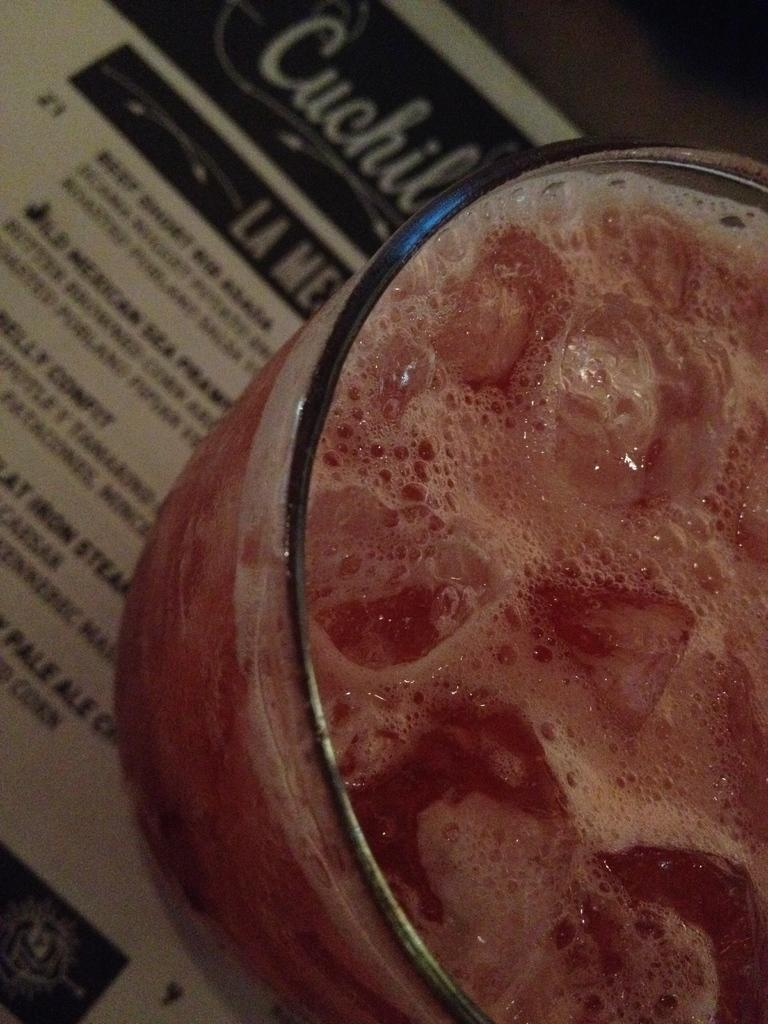What is in the glass that is visible in the image? There is a drink in the glass in the image. What other item can be seen in the image besides the glass? There is a paper in the image. How many beds are visible in the image? There are no beds present in the image. What is the wish of the person holding the paper in the image? There is no indication of a person holding the paper or any wishes in the image. 